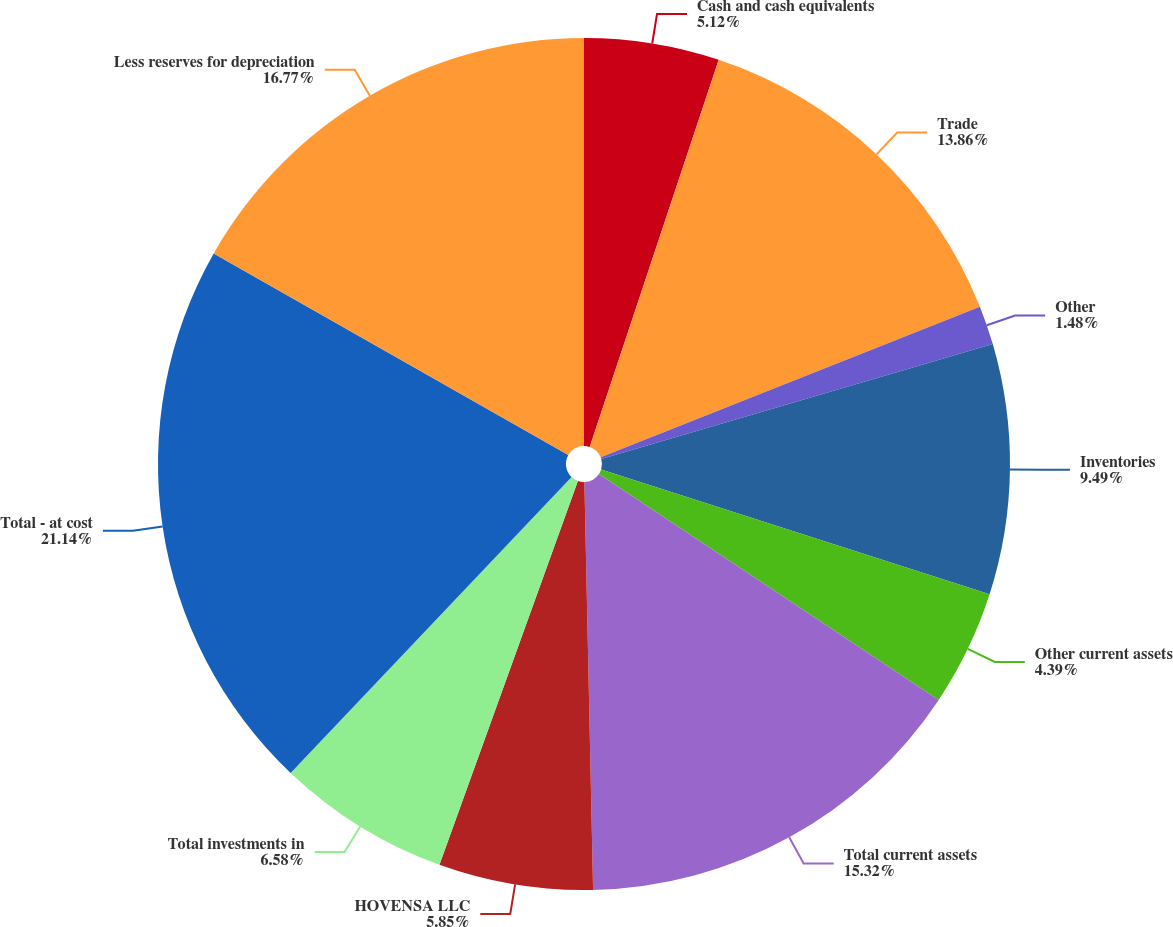<chart> <loc_0><loc_0><loc_500><loc_500><pie_chart><fcel>Cash and cash equivalents<fcel>Trade<fcel>Other<fcel>Inventories<fcel>Other current assets<fcel>Total current assets<fcel>HOVENSA LLC<fcel>Total investments in<fcel>Total - at cost<fcel>Less reserves for depreciation<nl><fcel>5.12%<fcel>13.86%<fcel>1.48%<fcel>9.49%<fcel>4.39%<fcel>15.32%<fcel>5.85%<fcel>6.58%<fcel>21.14%<fcel>16.77%<nl></chart> 